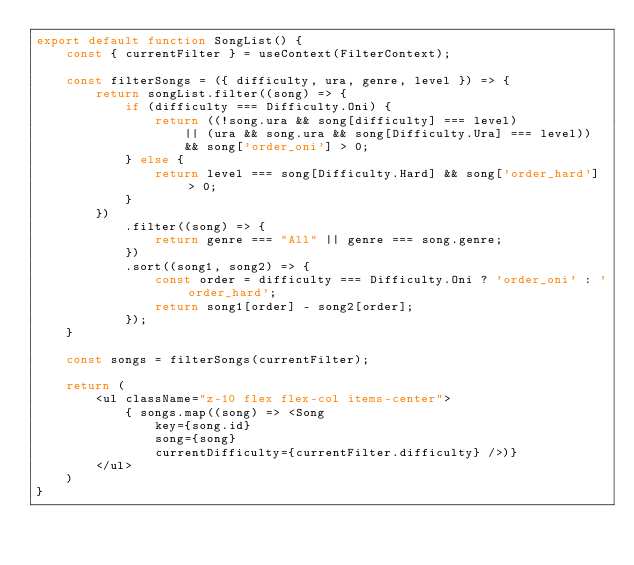<code> <loc_0><loc_0><loc_500><loc_500><_JavaScript_>export default function SongList() {
    const { currentFilter } = useContext(FilterContext);

    const filterSongs = ({ difficulty, ura, genre, level }) => {
        return songList.filter((song) => {
            if (difficulty === Difficulty.Oni) {
                return ((!song.ura && song[difficulty] === level)
                    || (ura && song.ura && song[Difficulty.Ura] === level))
                    && song['order_oni'] > 0;
            } else {
                return level === song[Difficulty.Hard] && song['order_hard'] > 0;
            }
        })
            .filter((song) => {
                return genre === "All" || genre === song.genre;
            })
            .sort((song1, song2) => {
                const order = difficulty === Difficulty.Oni ? 'order_oni' : 'order_hard';
                return song1[order] - song2[order];
            });
    }

    const songs = filterSongs(currentFilter);

    return (
        <ul className="z-10 flex flex-col items-center">
            { songs.map((song) => <Song
                key={song.id}
                song={song}
                currentDifficulty={currentFilter.difficulty} />)}
        </ul>
    )
}</code> 